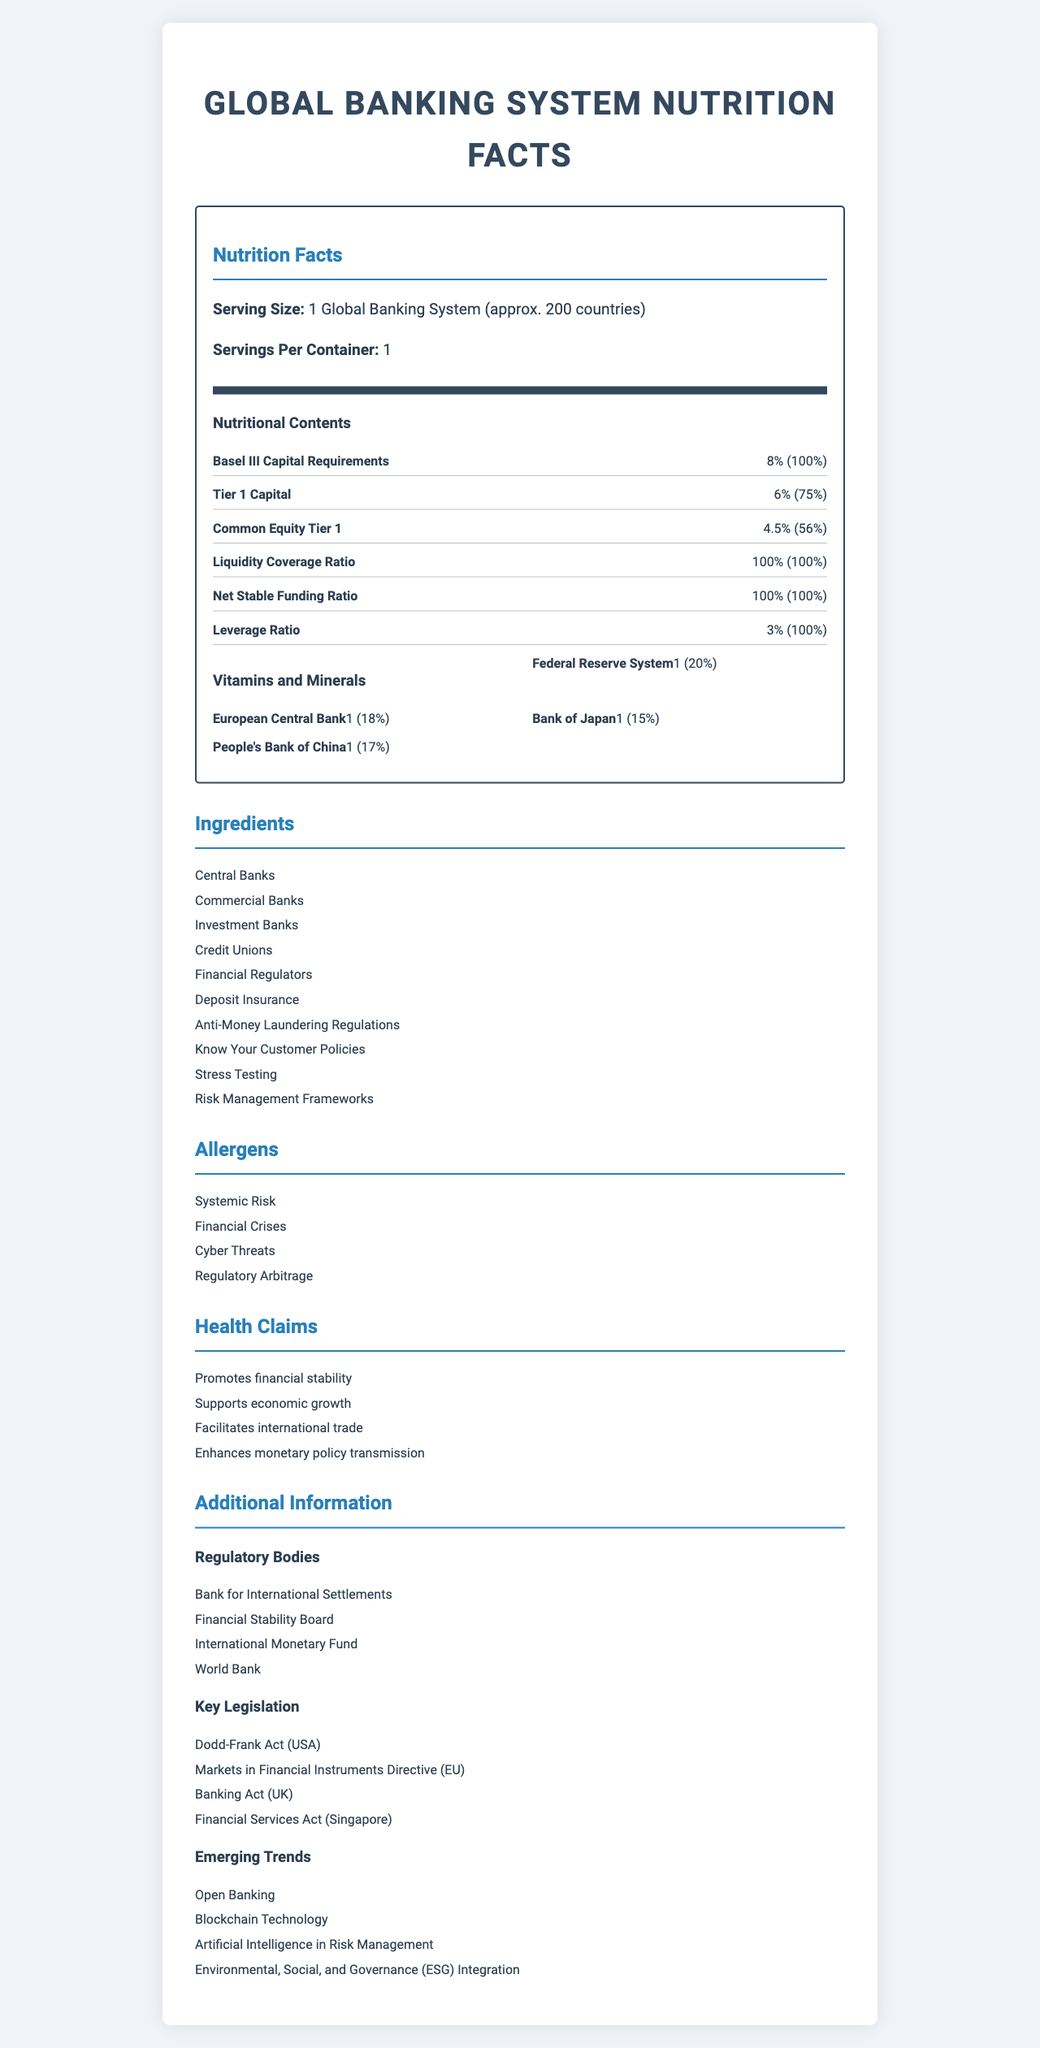what is the serving size mentioned in the document? The serving size is explicitly stated at the beginning of the document under "Serving Size."
Answer: 1 Global Banking System (approx. 200 countries) how much Tier 1 Capital is required based on Basel III requirements? The document lists Tier 1 Capital as having an amount of 6%.
Answer: 6% which regulatory component aligns with 100% daily value for leverage ratio? The leverage ratio has a daily value of 100%, as indicated in the document.
Answer: Leverage Ratio name two financial regulators included in the ingredients list. Both "Financial Regulators" and "Central Banks" are listed among the ingredients.
Answer: Financial Regulators, Central Banks who might use this document? The document provides detailed nutritional facts about the global banking system, useful for those involved in banking operations and management.
Answer: Regulatory bodies, financial analysts, banking professionals what are the risks mentioned that can affect the banking systems? A. Cyber Threats B. Deposits Loss C. Operational Failures D. Systemic Risk The document lists "Cyber Threats" and "Systemic Risk" under Allergens.
Answer: A and D which of the following is NOT stated as a health claim? I. Facilitates international trade II. Ensures constant liquidity III. Enhances monetary policy transmission "Ensures constant liquidity" is not mentioned; the other health claims listed are mentioned exactly as stated.
Answer: II. Ensures constant liquidity is Open Banking considered an emerging trend? Open Banking is listed under Emerging Trends in the document.
Answer: Yes summarize the document contents in one sentence. The document simulates a nutrition label for the global banking system, detailing capital requirements, ingredients, risks, benefits, and regulatory components.
Answer: The document provides a detailed "nutrition facts" breakdown of the global banking system, listing its regulatory requirements, key ingredients, potential risks, and emerging trends. name one key piece of legislation from a non-US country mentioned in the document. This directive is listed under Key Legislation and pertains to the EU.
Answer: Markets in Financial Instruments Directive (EU) what is the daily value contribution of the People's Bank of China according to the document? The People's Bank of China is listed with a daily value contribution of 17%.
Answer: 17% which institution is responsible for overseeing international financial stability according to the additional information section? The Financial Stability Board is listed under the Regulatory Bodies section, which oversees international financial stability.
Answer: Financial Stability Board can we find the number of commercial banks in the document? The document does not specify the number of commercial banks; it only lists "Commercial Banks" under ingredients without additional details.
Answer: Cannot be determined 